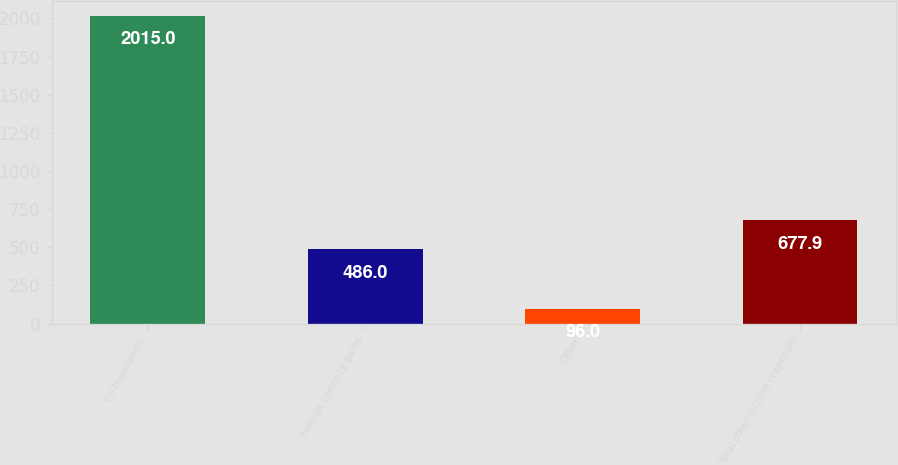Convert chart. <chart><loc_0><loc_0><loc_500><loc_500><bar_chart><fcel>(in thousands)<fcel>Foreign currency gains<fcel>Other<fcel>Total other income (expense)<nl><fcel>2015<fcel>486<fcel>96<fcel>677.9<nl></chart> 